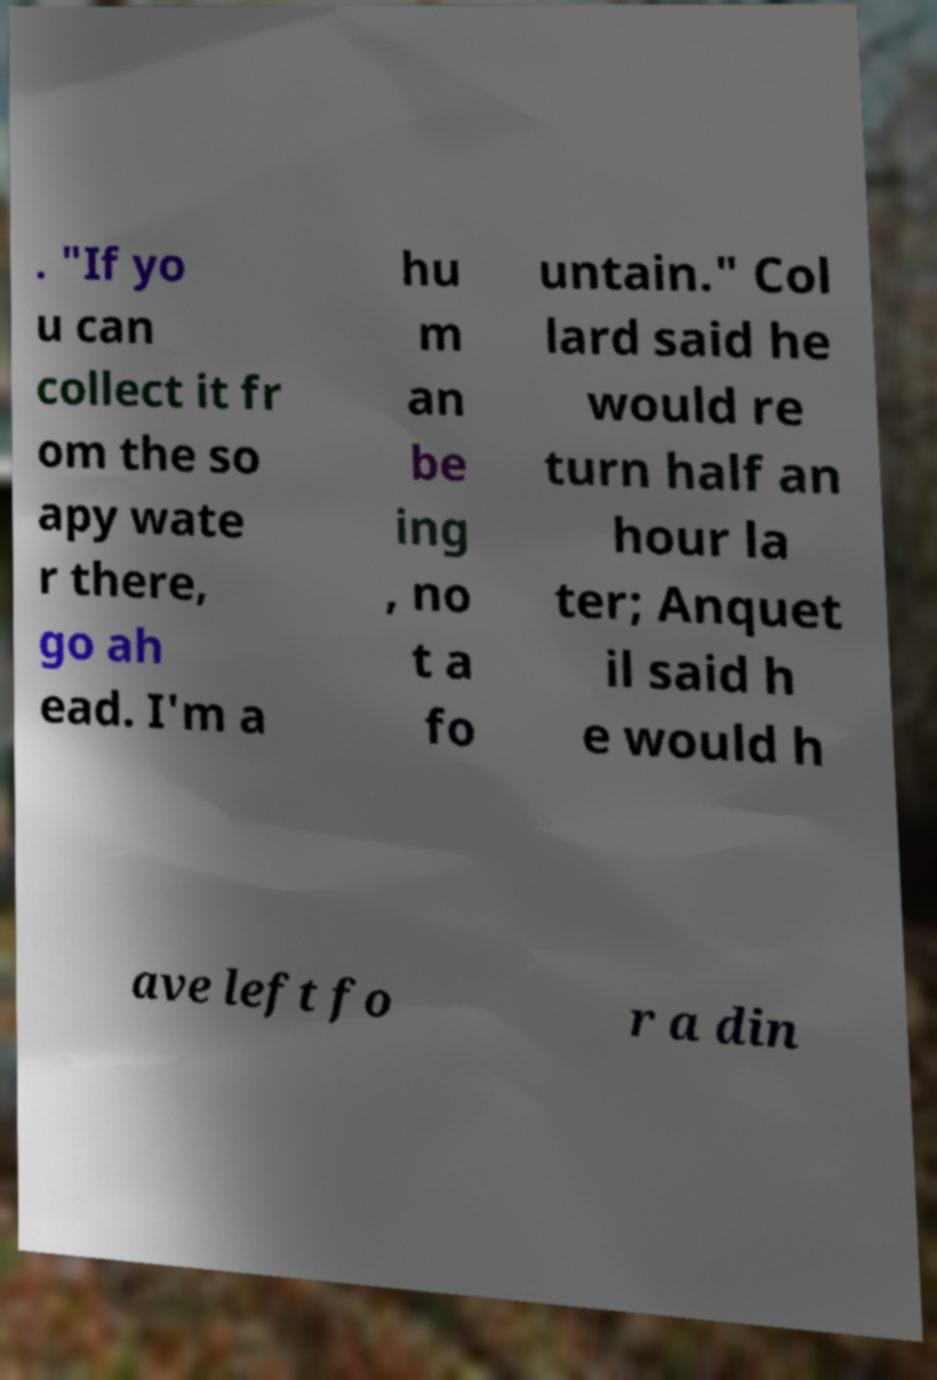For documentation purposes, I need the text within this image transcribed. Could you provide that? . "If yo u can collect it fr om the so apy wate r there, go ah ead. I'm a hu m an be ing , no t a fo untain." Col lard said he would re turn half an hour la ter; Anquet il said h e would h ave left fo r a din 